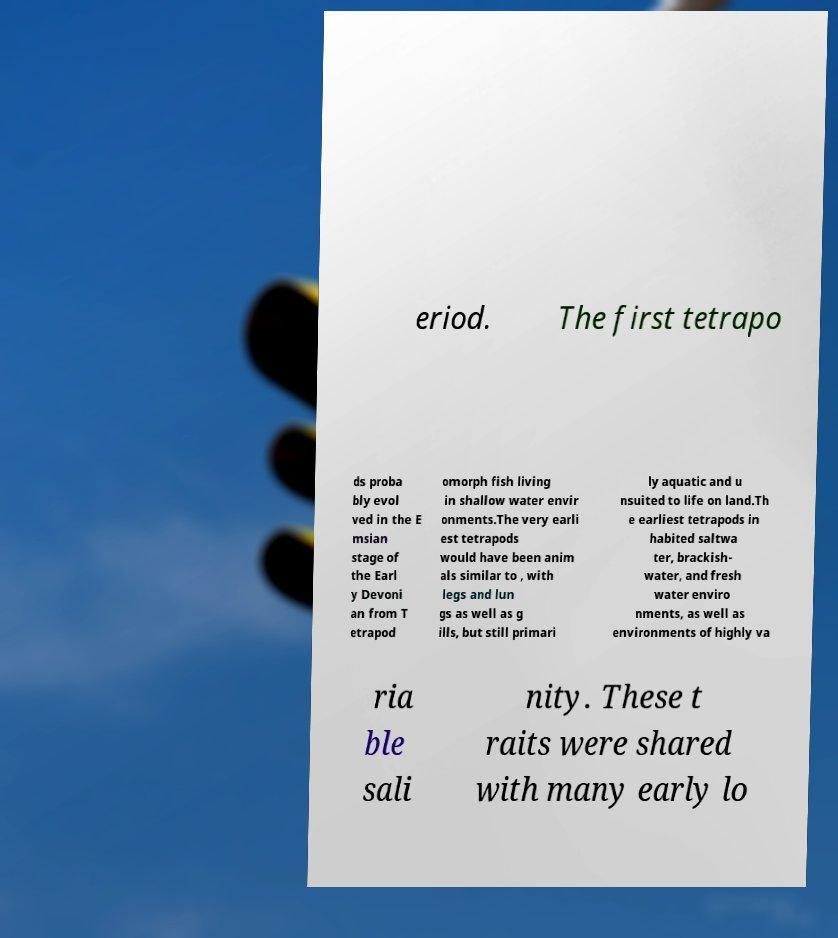Can you read and provide the text displayed in the image?This photo seems to have some interesting text. Can you extract and type it out for me? eriod. The first tetrapo ds proba bly evol ved in the E msian stage of the Earl y Devoni an from T etrapod omorph fish living in shallow water envir onments.The very earli est tetrapods would have been anim als similar to , with legs and lun gs as well as g ills, but still primari ly aquatic and u nsuited to life on land.Th e earliest tetrapods in habited saltwa ter, brackish- water, and fresh water enviro nments, as well as environments of highly va ria ble sali nity. These t raits were shared with many early lo 